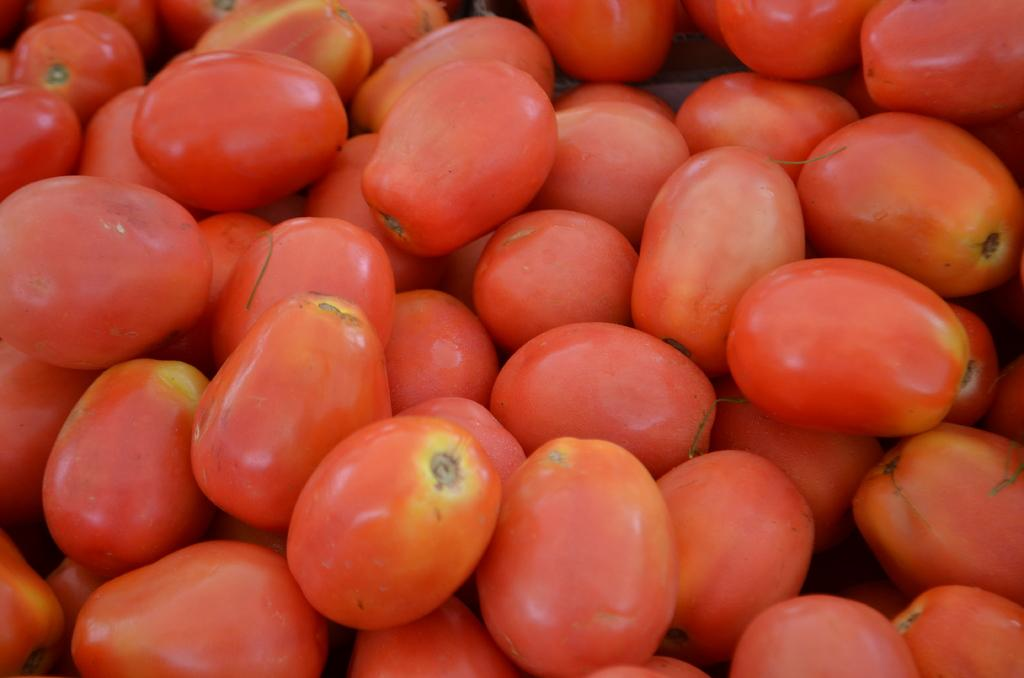What type of fruit can be seen in the image? There are tomatoes in the image. What color are the tomatoes? The tomatoes are red in color. How does the pollution affect the tomatoes in the image? There is no mention of pollution in the image, so we cannot determine its effect on the tomatoes. 